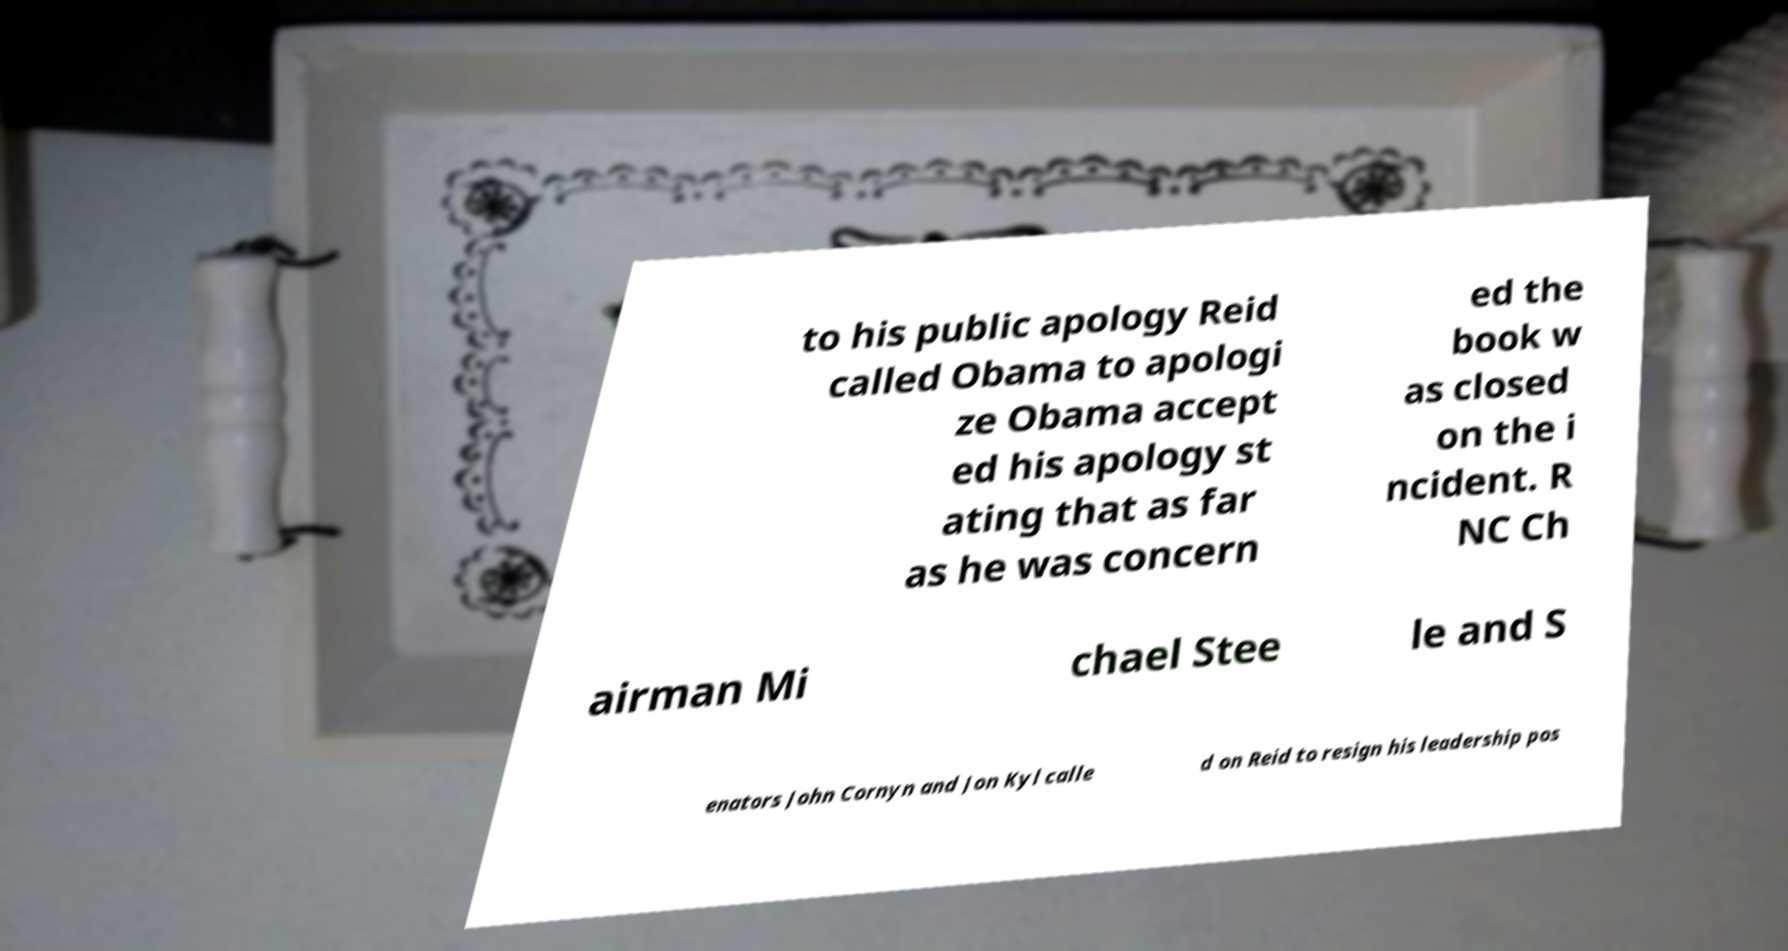Please read and relay the text visible in this image. What does it say? to his public apology Reid called Obama to apologi ze Obama accept ed his apology st ating that as far as he was concern ed the book w as closed on the i ncident. R NC Ch airman Mi chael Stee le and S enators John Cornyn and Jon Kyl calle d on Reid to resign his leadership pos 